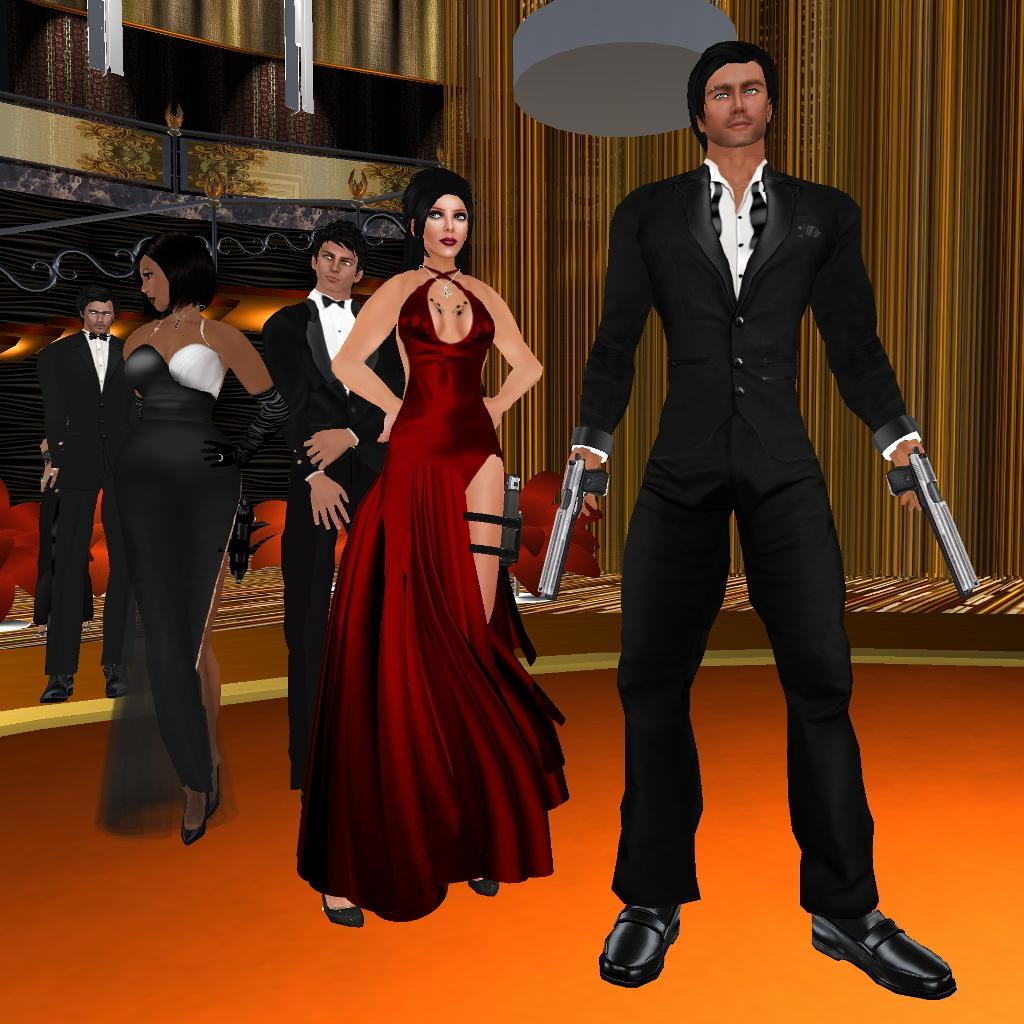Describe this image in one or two sentences. In this picture I can see few persons are standing in the middle, in the background there is the wall, it is an animated picture. 